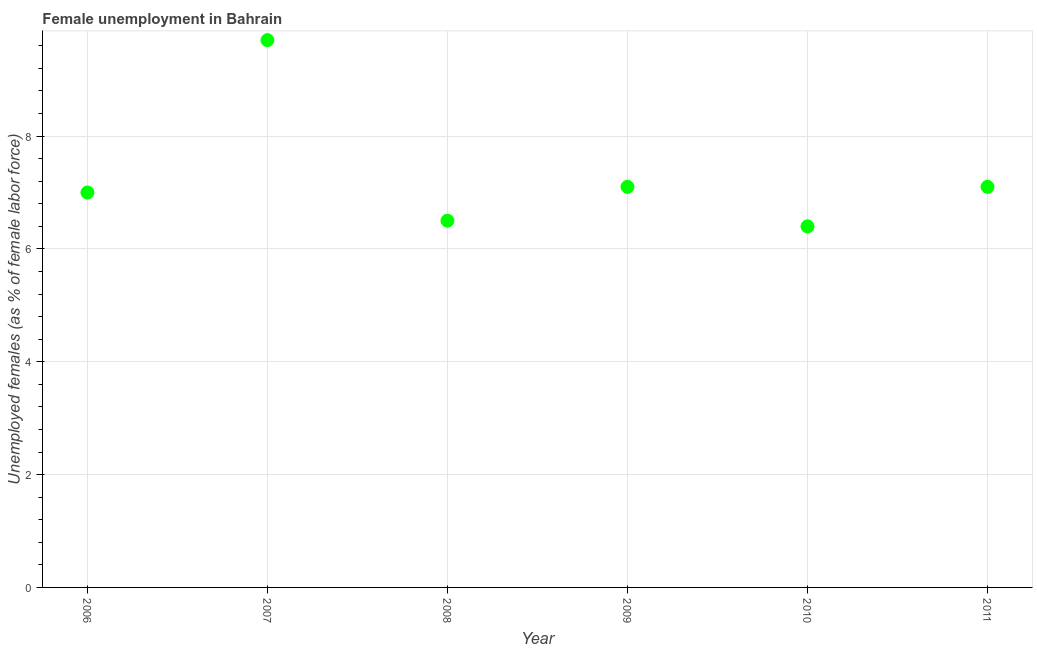Across all years, what is the maximum unemployed females population?
Your response must be concise. 9.7. Across all years, what is the minimum unemployed females population?
Provide a short and direct response. 6.4. In which year was the unemployed females population minimum?
Make the answer very short. 2010. What is the sum of the unemployed females population?
Make the answer very short. 43.8. What is the average unemployed females population per year?
Offer a terse response. 7.3. What is the median unemployed females population?
Provide a short and direct response. 7.05. What is the ratio of the unemployed females population in 2008 to that in 2009?
Ensure brevity in your answer.  0.92. Is the difference between the unemployed females population in 2010 and 2011 greater than the difference between any two years?
Ensure brevity in your answer.  No. What is the difference between the highest and the second highest unemployed females population?
Provide a succinct answer. 2.6. Is the sum of the unemployed females population in 2008 and 2011 greater than the maximum unemployed females population across all years?
Your response must be concise. Yes. What is the difference between the highest and the lowest unemployed females population?
Ensure brevity in your answer.  3.3. Does the unemployed females population monotonically increase over the years?
Offer a very short reply. No. How many years are there in the graph?
Give a very brief answer. 6. What is the difference between two consecutive major ticks on the Y-axis?
Your answer should be compact. 2. Are the values on the major ticks of Y-axis written in scientific E-notation?
Your answer should be very brief. No. What is the title of the graph?
Your answer should be compact. Female unemployment in Bahrain. What is the label or title of the Y-axis?
Provide a succinct answer. Unemployed females (as % of female labor force). What is the Unemployed females (as % of female labor force) in 2007?
Give a very brief answer. 9.7. What is the Unemployed females (as % of female labor force) in 2008?
Provide a succinct answer. 6.5. What is the Unemployed females (as % of female labor force) in 2009?
Offer a terse response. 7.1. What is the Unemployed females (as % of female labor force) in 2010?
Make the answer very short. 6.4. What is the Unemployed females (as % of female labor force) in 2011?
Provide a succinct answer. 7.1. What is the difference between the Unemployed females (as % of female labor force) in 2006 and 2010?
Keep it short and to the point. 0.6. What is the difference between the Unemployed females (as % of female labor force) in 2007 and 2011?
Make the answer very short. 2.6. What is the difference between the Unemployed females (as % of female labor force) in 2009 and 2011?
Your response must be concise. 0. What is the difference between the Unemployed females (as % of female labor force) in 2010 and 2011?
Your answer should be compact. -0.7. What is the ratio of the Unemployed females (as % of female labor force) in 2006 to that in 2007?
Make the answer very short. 0.72. What is the ratio of the Unemployed females (as % of female labor force) in 2006 to that in 2008?
Your response must be concise. 1.08. What is the ratio of the Unemployed females (as % of female labor force) in 2006 to that in 2009?
Keep it short and to the point. 0.99. What is the ratio of the Unemployed females (as % of female labor force) in 2006 to that in 2010?
Give a very brief answer. 1.09. What is the ratio of the Unemployed females (as % of female labor force) in 2006 to that in 2011?
Offer a very short reply. 0.99. What is the ratio of the Unemployed females (as % of female labor force) in 2007 to that in 2008?
Provide a short and direct response. 1.49. What is the ratio of the Unemployed females (as % of female labor force) in 2007 to that in 2009?
Ensure brevity in your answer.  1.37. What is the ratio of the Unemployed females (as % of female labor force) in 2007 to that in 2010?
Make the answer very short. 1.52. What is the ratio of the Unemployed females (as % of female labor force) in 2007 to that in 2011?
Your response must be concise. 1.37. What is the ratio of the Unemployed females (as % of female labor force) in 2008 to that in 2009?
Your answer should be very brief. 0.92. What is the ratio of the Unemployed females (as % of female labor force) in 2008 to that in 2011?
Provide a short and direct response. 0.92. What is the ratio of the Unemployed females (as % of female labor force) in 2009 to that in 2010?
Offer a terse response. 1.11. What is the ratio of the Unemployed females (as % of female labor force) in 2010 to that in 2011?
Offer a very short reply. 0.9. 